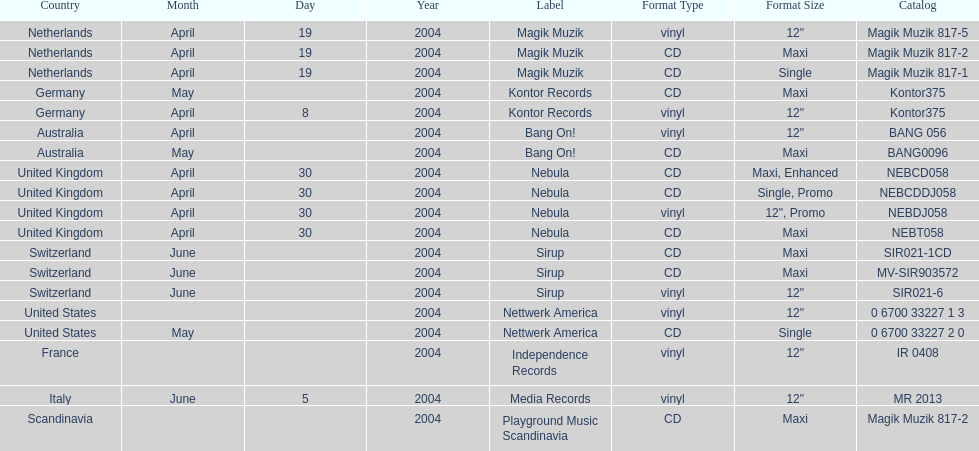What label was used by the netherlands in love comes again? Magik Muzik. Would you mind parsing the complete table? {'header': ['Country', 'Month', 'Day', 'Year', 'Label', 'Format Type', 'Format Size', 'Catalog'], 'rows': [['Netherlands', 'April', '19', '2004', 'Magik Muzik', 'vinyl', '12"', 'Magik Muzik 817-5'], ['Netherlands', 'April', '19', '2004', 'Magik Muzik', 'CD', 'Maxi', 'Magik Muzik 817-2'], ['Netherlands', 'April', '19', '2004', 'Magik Muzik', 'CD', 'Single', 'Magik Muzik 817-1'], ['Germany', 'May', '', '2004', 'Kontor Records', 'CD', 'Maxi', 'Kontor375'], ['Germany', 'April', '8', '2004', 'Kontor Records', 'vinyl', '12"', 'Kontor375'], ['Australia', 'April', '', '2004', 'Bang On!', 'vinyl', '12"', 'BANG 056'], ['Australia', 'May', '', '2004', 'Bang On!', 'CD', 'Maxi', 'BANG0096'], ['United Kingdom', 'April', '30', '2004', 'Nebula', 'CD', 'Maxi, Enhanced', 'NEBCD058'], ['United Kingdom', 'April', '30', '2004', 'Nebula', 'CD', 'Single, Promo', 'NEBCDDJ058'], ['United Kingdom', 'April', '30', '2004', 'Nebula', 'vinyl', '12", Promo', 'NEBDJ058'], ['United Kingdom', 'April', '30', '2004', 'Nebula', 'CD', 'Maxi', 'NEBT058'], ['Switzerland', 'June', '', '2004', 'Sirup', 'CD', 'Maxi', 'SIR021-1CD'], ['Switzerland', 'June', '', '2004', 'Sirup', 'CD', 'Maxi', 'MV-SIR903572'], ['Switzerland', 'June', '', '2004', 'Sirup', 'vinyl', '12"', 'SIR021-6'], ['United States', '', '', '2004', 'Nettwerk America', 'vinyl', '12"', '0 6700 33227 1 3'], ['United States', 'May', '', '2004', 'Nettwerk America', 'CD', 'Single', '0 6700 33227 2 0'], ['France', '', '', '2004', 'Independence Records', 'vinyl', '12"', 'IR 0408'], ['Italy', 'June', '5', '2004', 'Media Records', 'vinyl', '12"', 'MR 2013'], ['Scandinavia', '', '', '2004', 'Playground Music Scandinavia', 'CD', 'Maxi', 'Magik Muzik 817-2']]} What label was used in germany? Kontor Records. What label was used in france? Independence Records. 